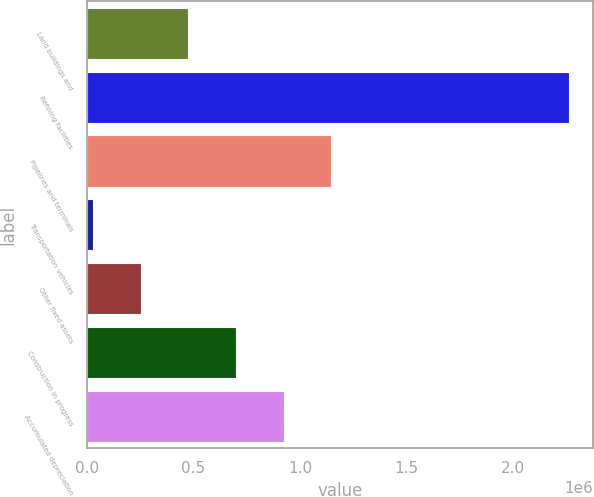Convert chart to OTSL. <chart><loc_0><loc_0><loc_500><loc_500><bar_chart><fcel>Land buildings and<fcel>Refining facilities<fcel>Pipelines and terminals<fcel>Transportation vehicles<fcel>Other fixed assets<fcel>Construction in progress<fcel>Accumulated depreciation<nl><fcel>476323<fcel>2.26173e+06<fcel>1.14585e+06<fcel>29970<fcel>253146<fcel>699499<fcel>922675<nl></chart> 